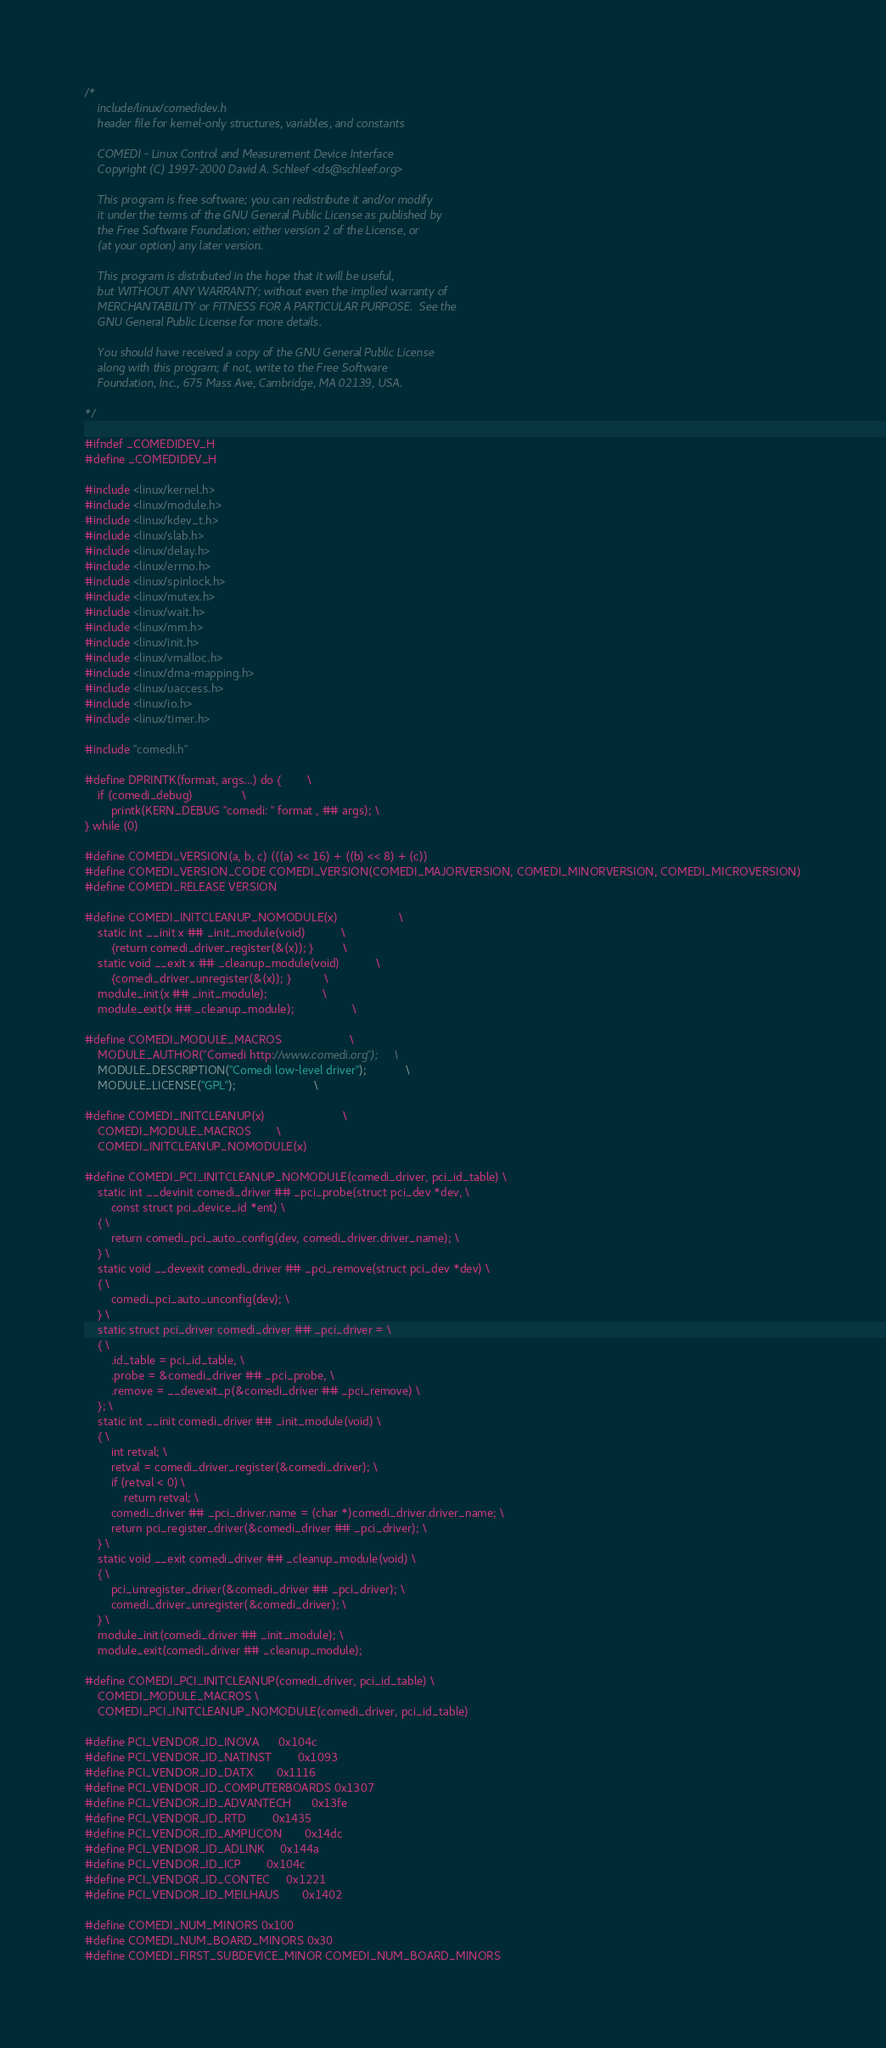<code> <loc_0><loc_0><loc_500><loc_500><_C_>/*
    include/linux/comedidev.h
    header file for kernel-only structures, variables, and constants

    COMEDI - Linux Control and Measurement Device Interface
    Copyright (C) 1997-2000 David A. Schleef <ds@schleef.org>

    This program is free software; you can redistribute it and/or modify
    it under the terms of the GNU General Public License as published by
    the Free Software Foundation; either version 2 of the License, or
    (at your option) any later version.

    This program is distributed in the hope that it will be useful,
    but WITHOUT ANY WARRANTY; without even the implied warranty of
    MERCHANTABILITY or FITNESS FOR A PARTICULAR PURPOSE.  See the
    GNU General Public License for more details.

    You should have received a copy of the GNU General Public License
    along with this program; if not, write to the Free Software
    Foundation, Inc., 675 Mass Ave, Cambridge, MA 02139, USA.

*/

#ifndef _COMEDIDEV_H
#define _COMEDIDEV_H

#include <linux/kernel.h>
#include <linux/module.h>
#include <linux/kdev_t.h>
#include <linux/slab.h>
#include <linux/delay.h>
#include <linux/errno.h>
#include <linux/spinlock.h>
#include <linux/mutex.h>
#include <linux/wait.h>
#include <linux/mm.h>
#include <linux/init.h>
#include <linux/vmalloc.h>
#include <linux/dma-mapping.h>
#include <linux/uaccess.h>
#include <linux/io.h>
#include <linux/timer.h>

#include "comedi.h"

#define DPRINTK(format, args...)	do {		\
	if (comedi_debug)				\
		printk(KERN_DEBUG "comedi: " format , ## args);	\
} while (0)

#define COMEDI_VERSION(a, b, c) (((a) << 16) + ((b) << 8) + (c))
#define COMEDI_VERSION_CODE COMEDI_VERSION(COMEDI_MAJORVERSION, COMEDI_MINORVERSION, COMEDI_MICROVERSION)
#define COMEDI_RELEASE VERSION

#define COMEDI_INITCLEANUP_NOMODULE(x)					\
	static int __init x ## _init_module(void)			\
		{return comedi_driver_register(&(x)); }			\
	static void __exit x ## _cleanup_module(void)			\
		{comedi_driver_unregister(&(x)); } 			\
	module_init(x ## _init_module);					\
	module_exit(x ## _cleanup_module);					\

#define COMEDI_MODULE_MACROS						\
	MODULE_AUTHOR("Comedi http://www.comedi.org");		\
	MODULE_DESCRIPTION("Comedi low-level driver");			\
	MODULE_LICENSE("GPL");						\

#define COMEDI_INITCLEANUP(x)						\
	COMEDI_MODULE_MACROS		\
	COMEDI_INITCLEANUP_NOMODULE(x)

#define COMEDI_PCI_INITCLEANUP_NOMODULE(comedi_driver, pci_id_table) \
	static int __devinit comedi_driver ## _pci_probe(struct pci_dev *dev, \
		const struct pci_device_id *ent) \
	{ \
		return comedi_pci_auto_config(dev, comedi_driver.driver_name); \
	} \
	static void __devexit comedi_driver ## _pci_remove(struct pci_dev *dev) \
	{ \
		comedi_pci_auto_unconfig(dev); \
	} \
	static struct pci_driver comedi_driver ## _pci_driver = \
	{ \
		.id_table = pci_id_table, \
		.probe = &comedi_driver ## _pci_probe, \
		.remove = __devexit_p(&comedi_driver ## _pci_remove) \
	}; \
	static int __init comedi_driver ## _init_module(void) \
	{ \
		int retval; \
		retval = comedi_driver_register(&comedi_driver); \
		if (retval < 0) \
			return retval; \
		comedi_driver ## _pci_driver.name = (char *)comedi_driver.driver_name; \
		return pci_register_driver(&comedi_driver ## _pci_driver); \
	} \
	static void __exit comedi_driver ## _cleanup_module(void) \
	{ \
		pci_unregister_driver(&comedi_driver ## _pci_driver); \
		comedi_driver_unregister(&comedi_driver); \
	} \
	module_init(comedi_driver ## _init_module); \
	module_exit(comedi_driver ## _cleanup_module);

#define COMEDI_PCI_INITCLEANUP(comedi_driver, pci_id_table) \
	COMEDI_MODULE_MACROS \
	COMEDI_PCI_INITCLEANUP_NOMODULE(comedi_driver, pci_id_table)

#define PCI_VENDOR_ID_INOVA		0x104c
#define PCI_VENDOR_ID_NATINST		0x1093
#define PCI_VENDOR_ID_DATX		0x1116
#define PCI_VENDOR_ID_COMPUTERBOARDS	0x1307
#define PCI_VENDOR_ID_ADVANTECH		0x13fe
#define PCI_VENDOR_ID_RTD		0x1435
#define PCI_VENDOR_ID_AMPLICON		0x14dc
#define PCI_VENDOR_ID_ADLINK		0x144a
#define PCI_VENDOR_ID_ICP		0x104c
#define PCI_VENDOR_ID_CONTEC		0x1221
#define PCI_VENDOR_ID_MEILHAUS		0x1402

#define COMEDI_NUM_MINORS 0x100
#define COMEDI_NUM_BOARD_MINORS 0x30
#define COMEDI_FIRST_SUBDEVICE_MINOR COMEDI_NUM_BOARD_MINORS
</code> 